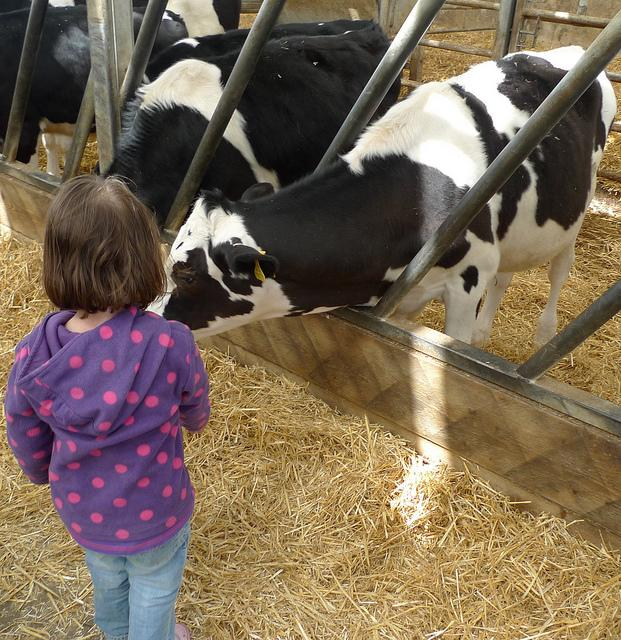What is near the cows? girl 